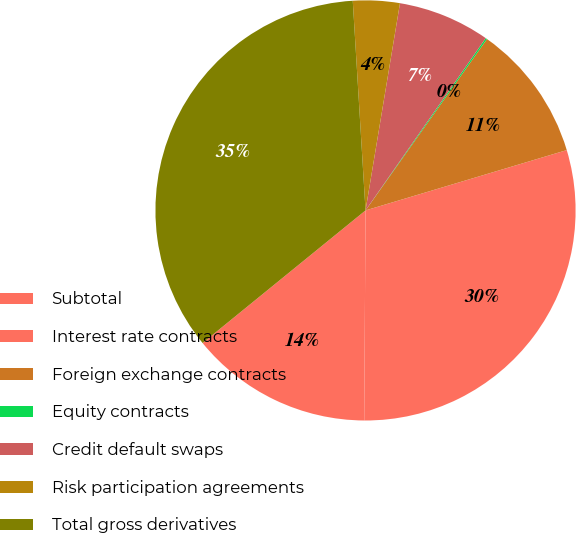Convert chart. <chart><loc_0><loc_0><loc_500><loc_500><pie_chart><fcel>Subtotal<fcel>Interest rate contracts<fcel>Foreign exchange contracts<fcel>Equity contracts<fcel>Credit default swaps<fcel>Risk participation agreements<fcel>Total gross derivatives<nl><fcel>14.03%<fcel>29.73%<fcel>10.55%<fcel>0.12%<fcel>7.07%<fcel>3.59%<fcel>34.9%<nl></chart> 